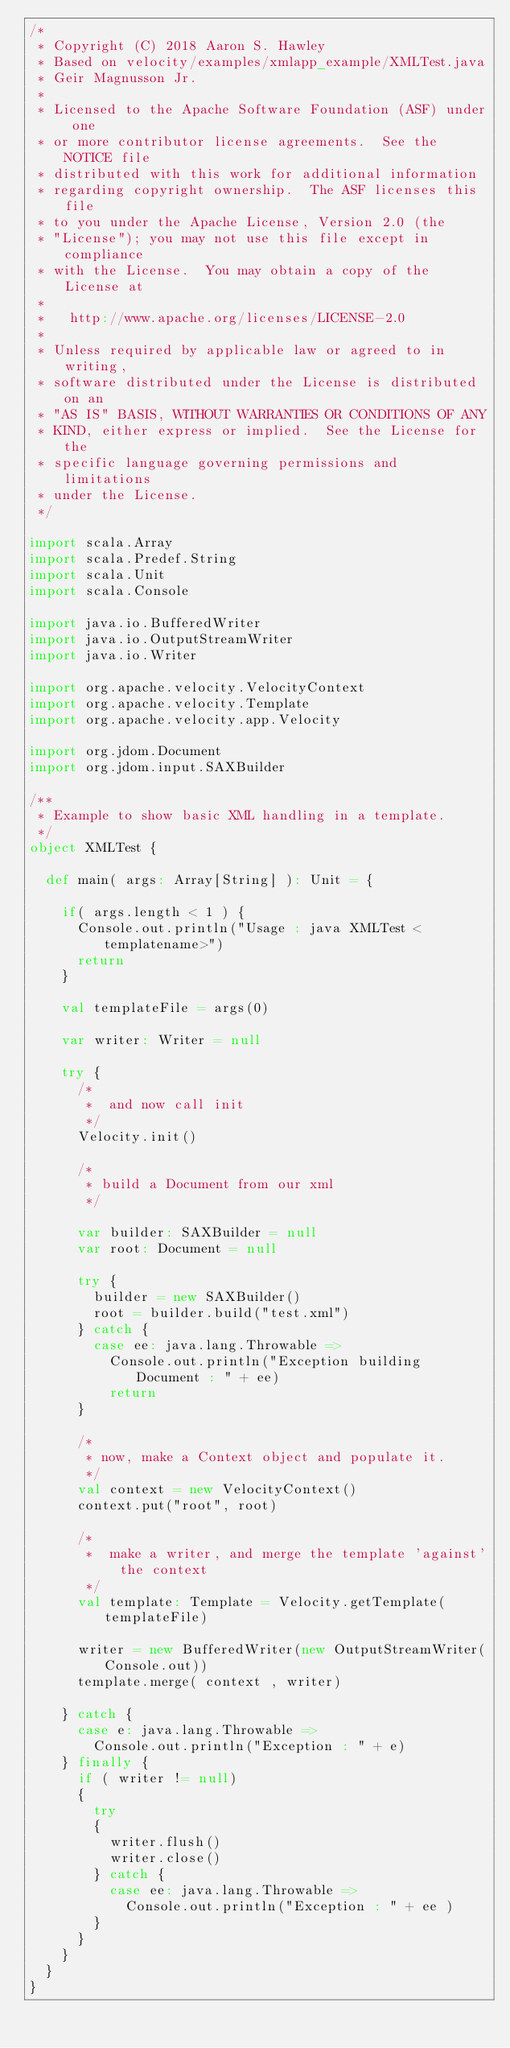<code> <loc_0><loc_0><loc_500><loc_500><_Scala_>/*
 * Copyright (C) 2018 Aaron S. Hawley
 * Based on velocity/examples/xmlapp_example/XMLTest.java
 * Geir Magnusson Jr.
 *
 * Licensed to the Apache Software Foundation (ASF) under one
 * or more contributor license agreements.  See the NOTICE file
 * distributed with this work for additional information
 * regarding copyright ownership.  The ASF licenses this file
 * to you under the Apache License, Version 2.0 (the
 * "License"); you may not use this file except in compliance
 * with the License.  You may obtain a copy of the License at
 *
 *   http://www.apache.org/licenses/LICENSE-2.0
 *
 * Unless required by applicable law or agreed to in writing,
 * software distributed under the License is distributed on an
 * "AS IS" BASIS, WITHOUT WARRANTIES OR CONDITIONS OF ANY
 * KIND, either express or implied.  See the License for the
 * specific language governing permissions and limitations
 * under the License.    
 */

import scala.Array
import scala.Predef.String
import scala.Unit
import scala.Console

import java.io.BufferedWriter
import java.io.OutputStreamWriter
import java.io.Writer

import org.apache.velocity.VelocityContext
import org.apache.velocity.Template
import org.apache.velocity.app.Velocity

import org.jdom.Document
import org.jdom.input.SAXBuilder

/**
 * Example to show basic XML handling in a template.
 */
object XMLTest {

  def main( args: Array[String] ): Unit = {

    if( args.length < 1 ) {
      Console.out.println("Usage : java XMLTest <templatename>")
      return
    }

    val templateFile = args(0)

    var writer: Writer = null
                        
    try {
      /*
       *  and now call init
       */
      Velocity.init()

      /*
       * build a Document from our xml
       */

      var builder: SAXBuilder = null
      var root: Document = null

      try {
        builder = new SAXBuilder()
        root = builder.build("test.xml")
      } catch {
        case ee: java.lang.Throwable =>
          Console.out.println("Exception building Document : " + ee)
          return
      }

      /*
       * now, make a Context object and populate it.
       */
      val context = new VelocityContext()
      context.put("root", root)

      /*
       *  make a writer, and merge the template 'against' the context
       */
      val template: Template = Velocity.getTemplate(templateFile)

      writer = new BufferedWriter(new OutputStreamWriter(Console.out))
      template.merge( context , writer)

    } catch {
      case e: java.lang.Throwable =>
        Console.out.println("Exception : " + e)
    } finally {
      if ( writer != null)
      {
        try
        {
          writer.flush()
          writer.close()
        } catch {
          case ee: java.lang.Throwable =>
            Console.out.println("Exception : " + ee )
        }
      }
    }
  }
}
</code> 